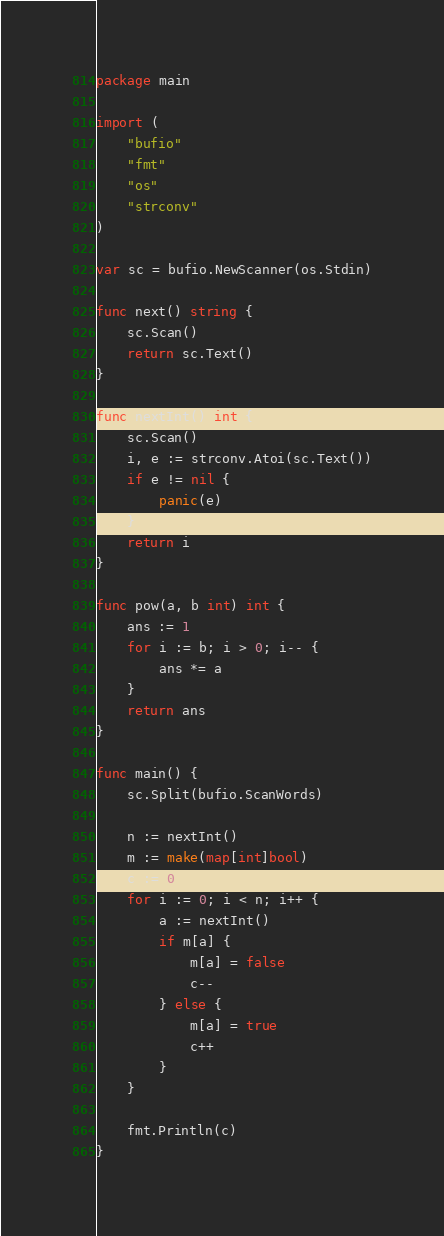Convert code to text. <code><loc_0><loc_0><loc_500><loc_500><_Go_>package main

import (
	"bufio"
	"fmt"
	"os"
	"strconv"
)

var sc = bufio.NewScanner(os.Stdin)

func next() string {
	sc.Scan()
	return sc.Text()
}

func nextInt() int {
	sc.Scan()
	i, e := strconv.Atoi(sc.Text())
	if e != nil {
		panic(e)
	}
	return i
}

func pow(a, b int) int {
	ans := 1
	for i := b; i > 0; i-- {
		ans *= a
	}
	return ans
}

func main() {
	sc.Split(bufio.ScanWords)

	n := nextInt()
	m := make(map[int]bool)
	c := 0
	for i := 0; i < n; i++ {
		a := nextInt()
		if m[a] {
			m[a] = false
			c--
		} else {
			m[a] = true
			c++
		}
	}

	fmt.Println(c)
}
</code> 